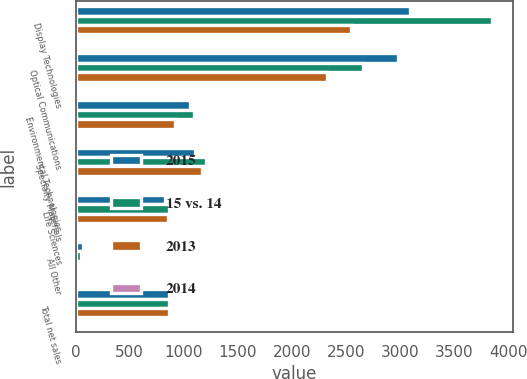<chart> <loc_0><loc_0><loc_500><loc_500><stacked_bar_chart><ecel><fcel>Display Technologies<fcel>Optical Communications<fcel>Environmental Technologies<fcel>Specialty Materials<fcel>Life Sciences<fcel>All Other<fcel>Total net sales<nl><fcel>2015<fcel>3086<fcel>2980<fcel>1053<fcel>1107<fcel>821<fcel>64<fcel>862<nl><fcel>15 vs. 14<fcel>3851<fcel>2652<fcel>1092<fcel>1205<fcel>862<fcel>53<fcel>862<nl><fcel>2013<fcel>2545<fcel>2326<fcel>919<fcel>1170<fcel>851<fcel>8<fcel>862<nl><fcel>2014<fcel>20<fcel>12<fcel>4<fcel>8<fcel>5<fcel>21<fcel>6<nl></chart> 